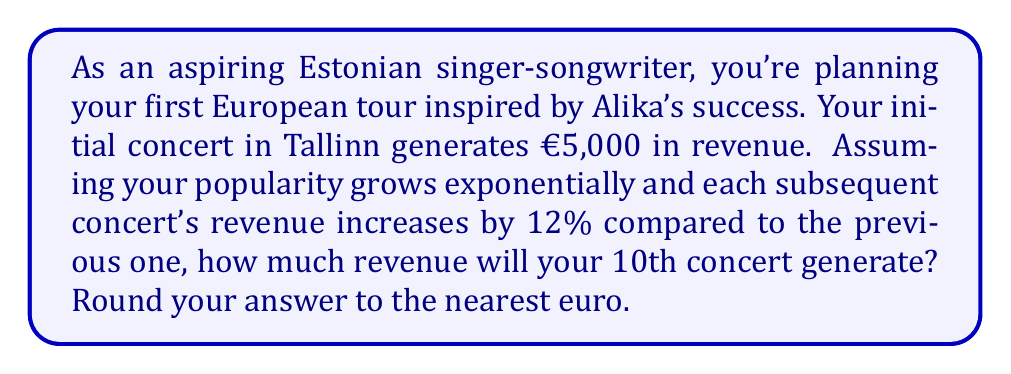Solve this math problem. Let's approach this problem step by step using an exponential function:

1) Let's define our variables:
   $a$ = initial revenue (€5,000)
   $r$ = growth rate (12% = 0.12)
   $n$ = number of concerts after the initial one (9, as we're looking at the 10th concert)

2) The exponential function for revenue growth is:
   $f(n) = a(1+r)^n$

3) Substituting our values:
   $f(9) = 5000(1+0.12)^9$

4) Let's calculate this:
   $f(9) = 5000(1.12)^9$
   
5) Using a calculator:
   $f(9) = 5000 * 2.772589991$
   $f(9) = 13862.94996$

6) Rounding to the nearest euro:
   $f(9) ≈ 13863$

Therefore, the 10th concert will generate approximately €13,863 in revenue.
Answer: €13,863 